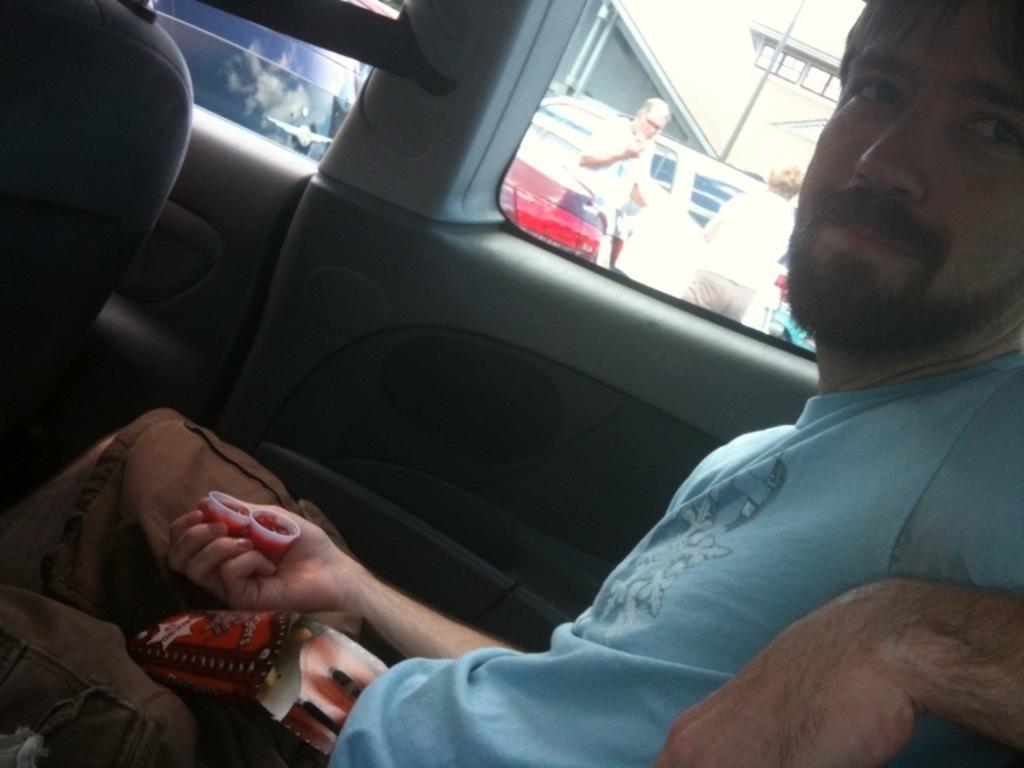Can you describe this image briefly? I can see in this image a man is sitting in a car. The man is wearing a blue t-shirt. In the background I can see the other vehicles and people who are standing on the ground. 